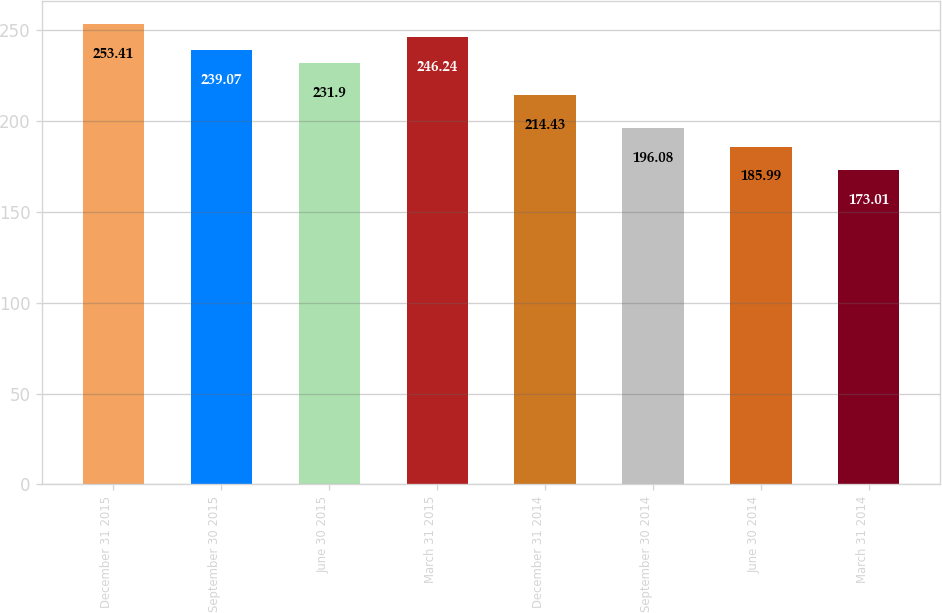<chart> <loc_0><loc_0><loc_500><loc_500><bar_chart><fcel>December 31 2015<fcel>September 30 2015<fcel>June 30 2015<fcel>March 31 2015<fcel>December 31 2014<fcel>September 30 2014<fcel>June 30 2014<fcel>March 31 2014<nl><fcel>253.41<fcel>239.07<fcel>231.9<fcel>246.24<fcel>214.43<fcel>196.08<fcel>185.99<fcel>173.01<nl></chart> 